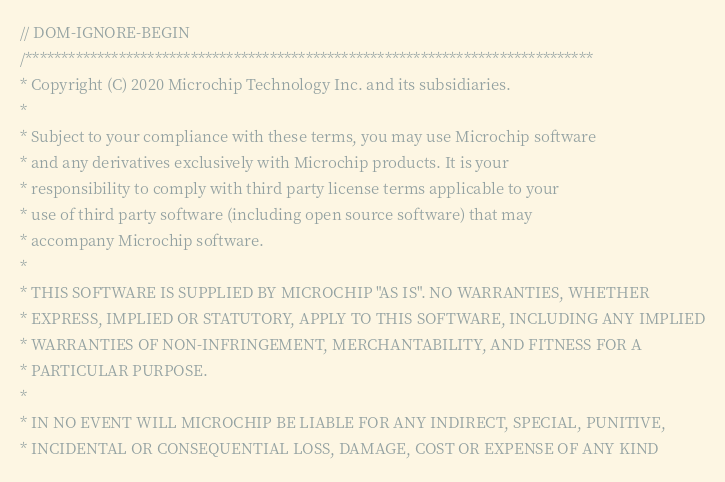<code> <loc_0><loc_0><loc_500><loc_500><_C_>// DOM-IGNORE-BEGIN
/*******************************************************************************
* Copyright (C) 2020 Microchip Technology Inc. and its subsidiaries.
*
* Subject to your compliance with these terms, you may use Microchip software
* and any derivatives exclusively with Microchip products. It is your
* responsibility to comply with third party license terms applicable to your
* use of third party software (including open source software) that may
* accompany Microchip software.
*
* THIS SOFTWARE IS SUPPLIED BY MICROCHIP "AS IS". NO WARRANTIES, WHETHER
* EXPRESS, IMPLIED OR STATUTORY, APPLY TO THIS SOFTWARE, INCLUDING ANY IMPLIED
* WARRANTIES OF NON-INFRINGEMENT, MERCHANTABILITY, AND FITNESS FOR A
* PARTICULAR PURPOSE.
*
* IN NO EVENT WILL MICROCHIP BE LIABLE FOR ANY INDIRECT, SPECIAL, PUNITIVE,
* INCIDENTAL OR CONSEQUENTIAL LOSS, DAMAGE, COST OR EXPENSE OF ANY KIND</code> 